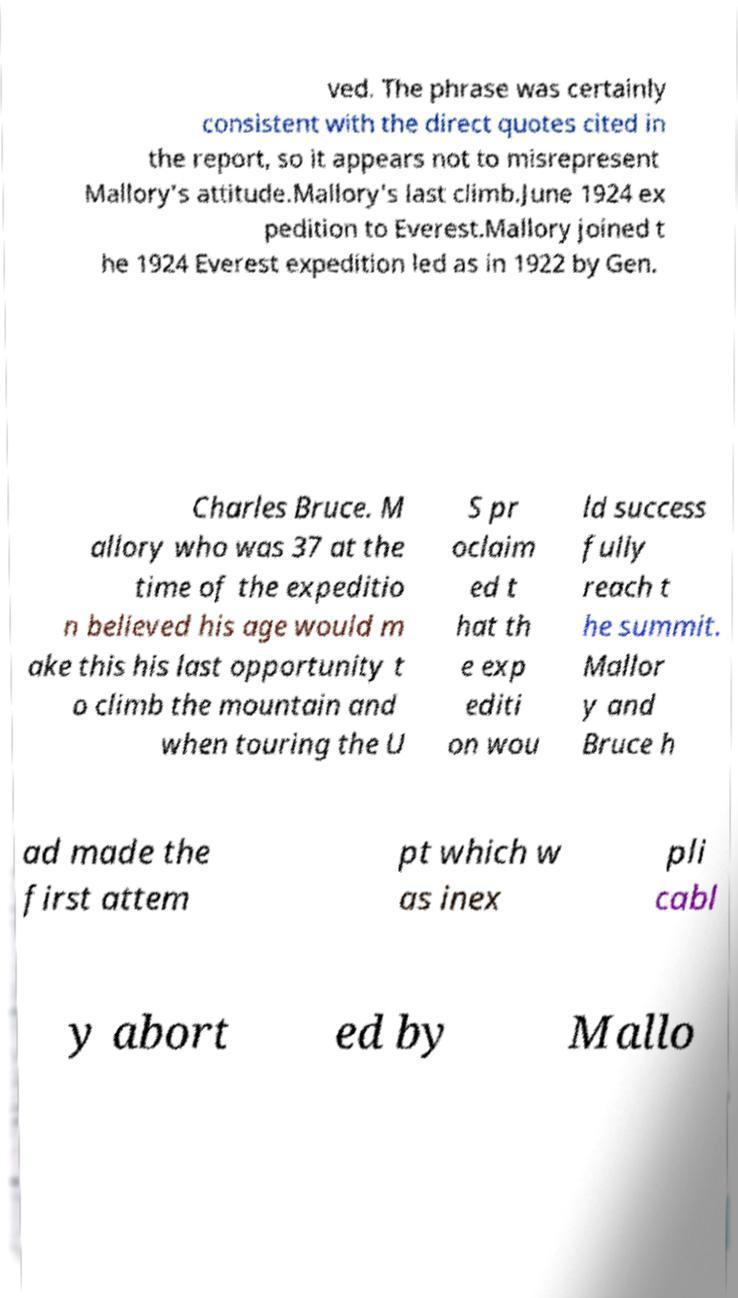What messages or text are displayed in this image? I need them in a readable, typed format. ved. The phrase was certainly consistent with the direct quotes cited in the report, so it appears not to misrepresent Mallory's attitude.Mallory's last climb.June 1924 ex pedition to Everest.Mallory joined t he 1924 Everest expedition led as in 1922 by Gen. Charles Bruce. M allory who was 37 at the time of the expeditio n believed his age would m ake this his last opportunity t o climb the mountain and when touring the U S pr oclaim ed t hat th e exp editi on wou ld success fully reach t he summit. Mallor y and Bruce h ad made the first attem pt which w as inex pli cabl y abort ed by Mallo 